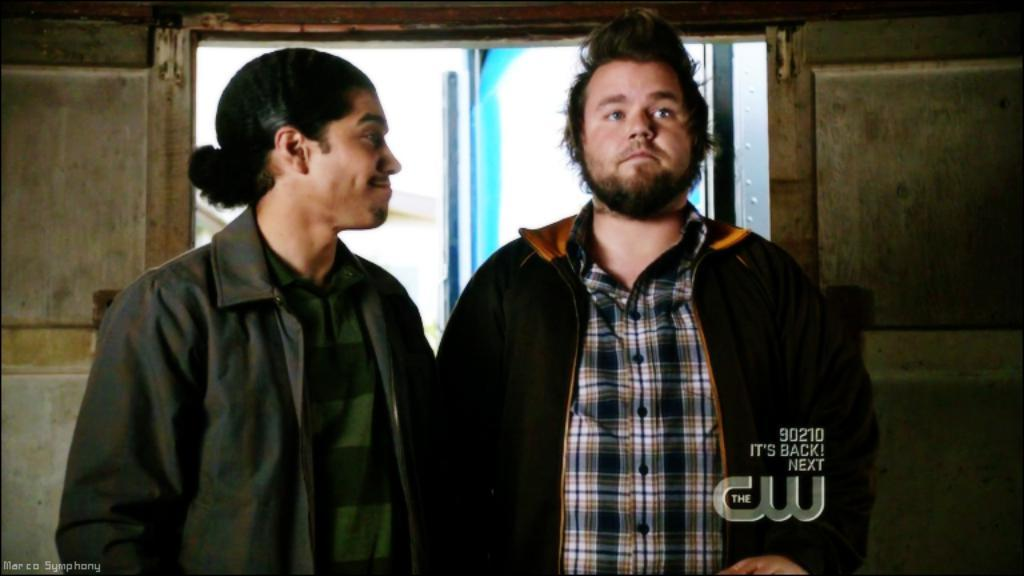How many people are in the image? There are two persons in the image. What are the persons wearing? Both persons are wearing jackets. What can be seen in the background of the image? There is a wall and a window in the background of the image. What type of committee is meeting in the image? There is no committee meeting in the image; it features two persons wearing jackets in front of a wall and a window. Can you see a gun in the image? There is no gun present in the image. 